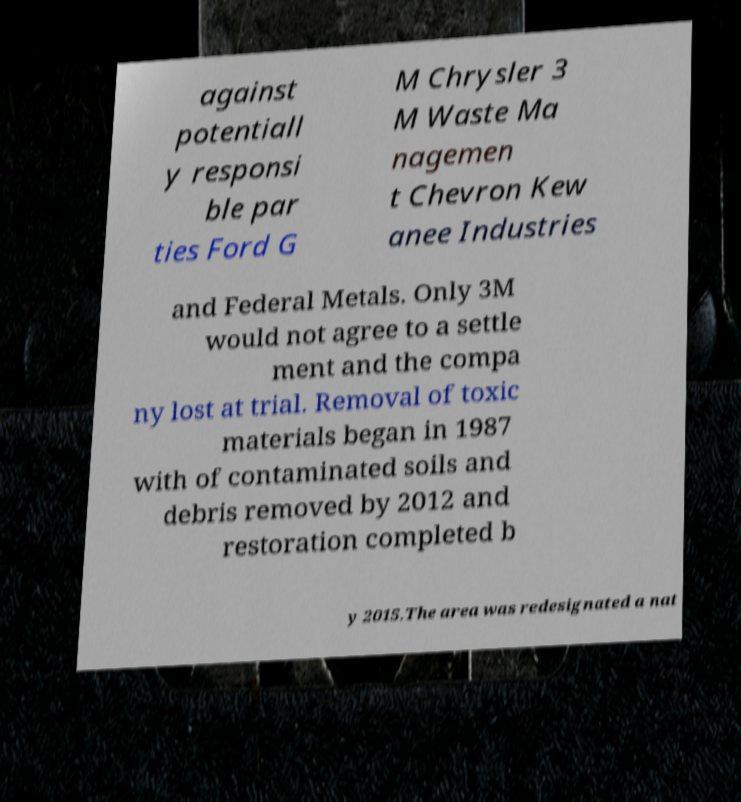Can you accurately transcribe the text from the provided image for me? against potentiall y responsi ble par ties Ford G M Chrysler 3 M Waste Ma nagemen t Chevron Kew anee Industries and Federal Metals. Only 3M would not agree to a settle ment and the compa ny lost at trial. Removal of toxic materials began in 1987 with of contaminated soils and debris removed by 2012 and restoration completed b y 2015.The area was redesignated a nat 